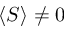Convert formula to latex. <formula><loc_0><loc_0><loc_500><loc_500>\langle S \rangle \neq 0</formula> 